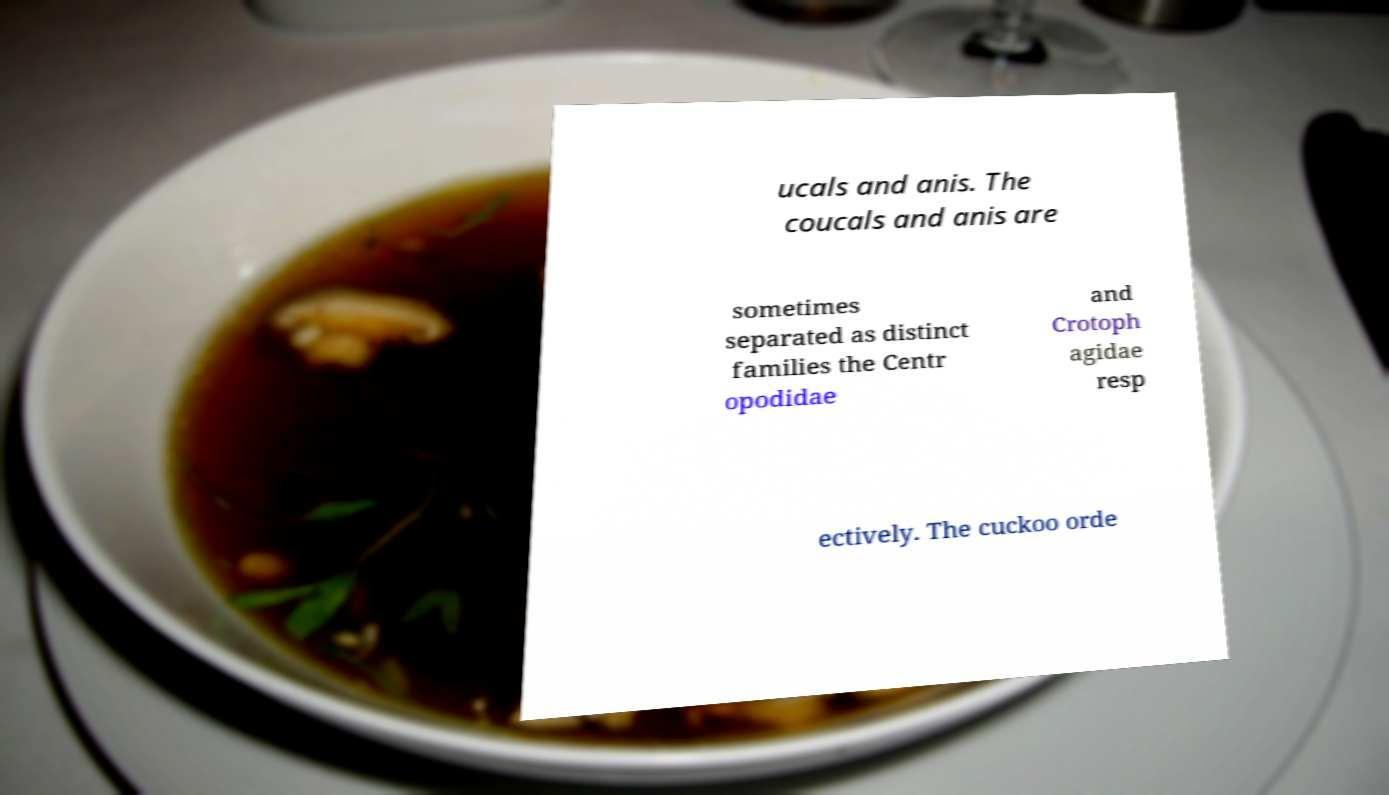I need the written content from this picture converted into text. Can you do that? ucals and anis. The coucals and anis are sometimes separated as distinct families the Centr opodidae and Crotoph agidae resp ectively. The cuckoo orde 